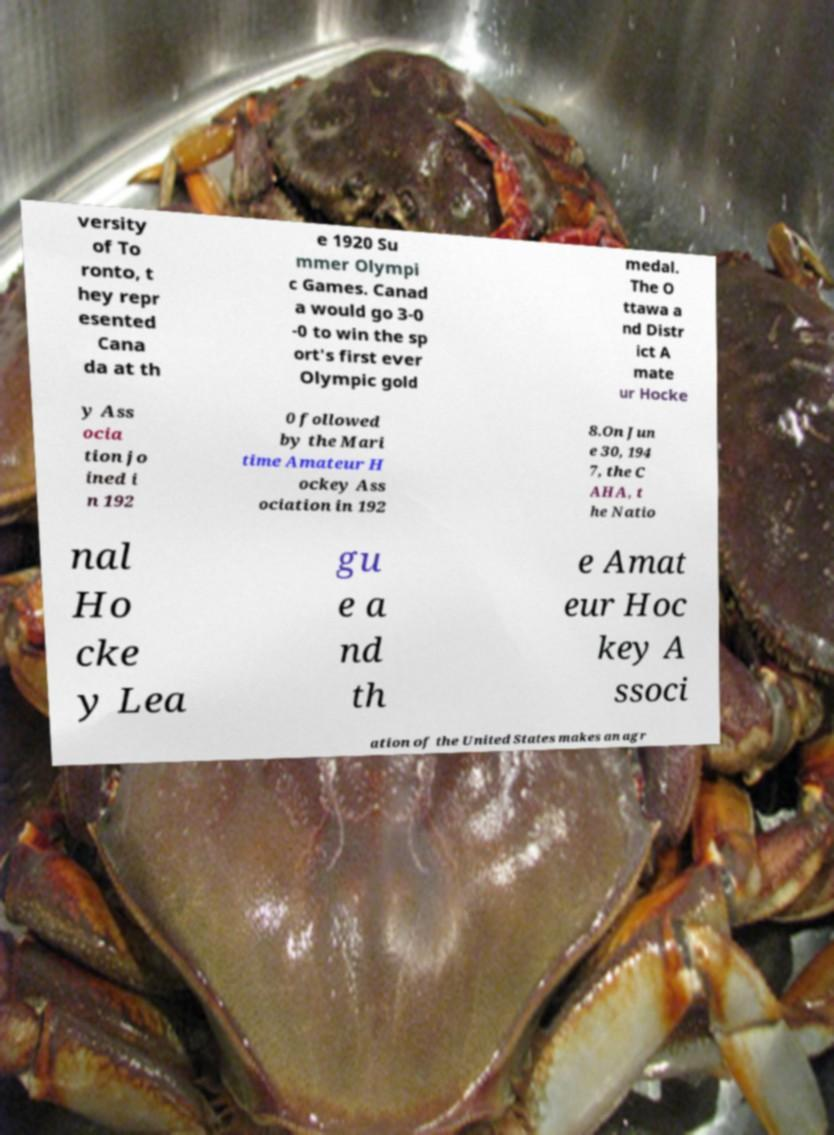Could you assist in decoding the text presented in this image and type it out clearly? versity of To ronto, t hey repr esented Cana da at th e 1920 Su mmer Olympi c Games. Canad a would go 3-0 -0 to win the sp ort's first ever Olympic gold medal. The O ttawa a nd Distr ict A mate ur Hocke y Ass ocia tion jo ined i n 192 0 followed by the Mari time Amateur H ockey Ass ociation in 192 8.On Jun e 30, 194 7, the C AHA, t he Natio nal Ho cke y Lea gu e a nd th e Amat eur Hoc key A ssoci ation of the United States makes an agr 